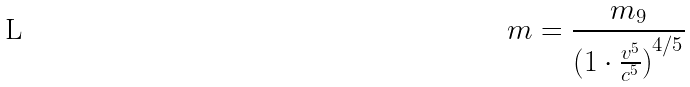<formula> <loc_0><loc_0><loc_500><loc_500>m = \frac { m _ { 9 } } { ( { 1 \cdot \frac { v ^ { 5 } } { c ^ { 5 } } ) } ^ { 4 / 5 } }</formula> 